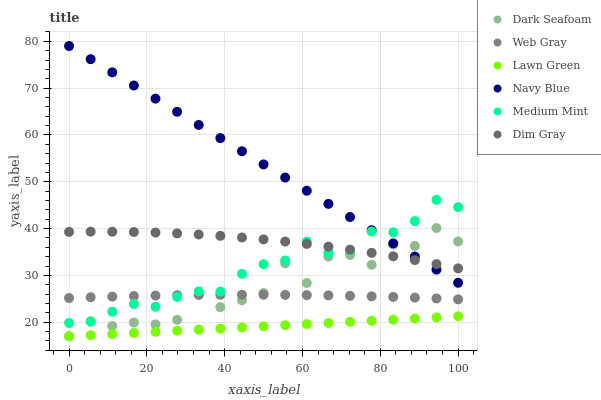Does Lawn Green have the minimum area under the curve?
Answer yes or no. Yes. Does Navy Blue have the maximum area under the curve?
Answer yes or no. Yes. Does Web Gray have the minimum area under the curve?
Answer yes or no. No. Does Web Gray have the maximum area under the curve?
Answer yes or no. No. Is Lawn Green the smoothest?
Answer yes or no. Yes. Is Dark Seafoam the roughest?
Answer yes or no. Yes. Is Web Gray the smoothest?
Answer yes or no. No. Is Web Gray the roughest?
Answer yes or no. No. Does Lawn Green have the lowest value?
Answer yes or no. Yes. Does Web Gray have the lowest value?
Answer yes or no. No. Does Navy Blue have the highest value?
Answer yes or no. Yes. Does Web Gray have the highest value?
Answer yes or no. No. Is Lawn Green less than Dim Gray?
Answer yes or no. Yes. Is Web Gray greater than Lawn Green?
Answer yes or no. Yes. Does Dark Seafoam intersect Medium Mint?
Answer yes or no. Yes. Is Dark Seafoam less than Medium Mint?
Answer yes or no. No. Is Dark Seafoam greater than Medium Mint?
Answer yes or no. No. Does Lawn Green intersect Dim Gray?
Answer yes or no. No. 